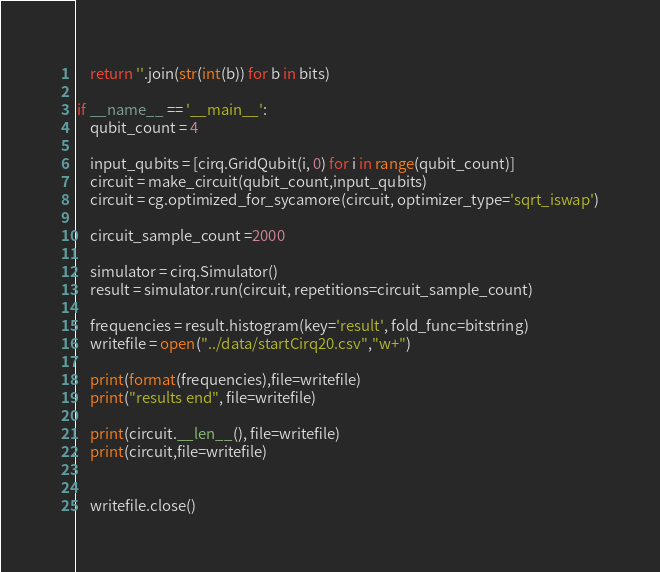<code> <loc_0><loc_0><loc_500><loc_500><_Python_>    return ''.join(str(int(b)) for b in bits)

if __name__ == '__main__':
    qubit_count = 4

    input_qubits = [cirq.GridQubit(i, 0) for i in range(qubit_count)]
    circuit = make_circuit(qubit_count,input_qubits)
    circuit = cg.optimized_for_sycamore(circuit, optimizer_type='sqrt_iswap')

    circuit_sample_count =2000

    simulator = cirq.Simulator()
    result = simulator.run(circuit, repetitions=circuit_sample_count)

    frequencies = result.histogram(key='result', fold_func=bitstring)
    writefile = open("../data/startCirq20.csv","w+")

    print(format(frequencies),file=writefile)
    print("results end", file=writefile)

    print(circuit.__len__(), file=writefile)
    print(circuit,file=writefile)


    writefile.close()</code> 